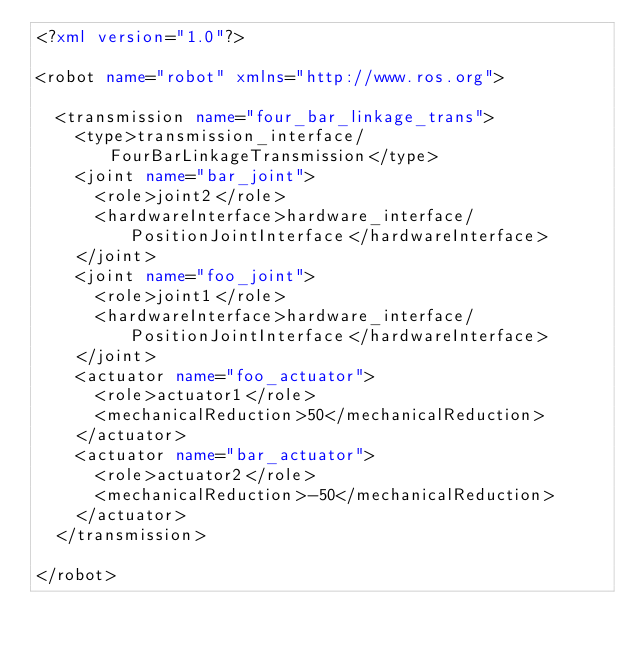<code> <loc_0><loc_0><loc_500><loc_500><_XML_><?xml version="1.0"?>

<robot name="robot" xmlns="http://www.ros.org">

  <transmission name="four_bar_linkage_trans">
    <type>transmission_interface/FourBarLinkageTransmission</type>
    <joint name="bar_joint">
      <role>joint2</role>
      <hardwareInterface>hardware_interface/PositionJointInterface</hardwareInterface>
    </joint>
    <joint name="foo_joint">
      <role>joint1</role>
      <hardwareInterface>hardware_interface/PositionJointInterface</hardwareInterface>
    </joint>
    <actuator name="foo_actuator">
      <role>actuator1</role>
      <mechanicalReduction>50</mechanicalReduction>
    </actuator>
    <actuator name="bar_actuator">
      <role>actuator2</role>
      <mechanicalReduction>-50</mechanicalReduction>
    </actuator>
  </transmission>

</robot>
</code> 